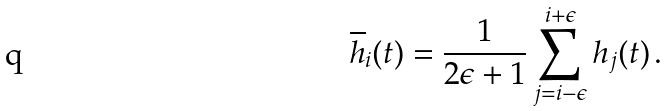<formula> <loc_0><loc_0><loc_500><loc_500>\overline { h } _ { i } ( t ) = \frac { 1 } { 2 \epsilon + 1 } \sum _ { j = i - \epsilon } ^ { i + \epsilon } h _ { j } ( t ) \, .</formula> 